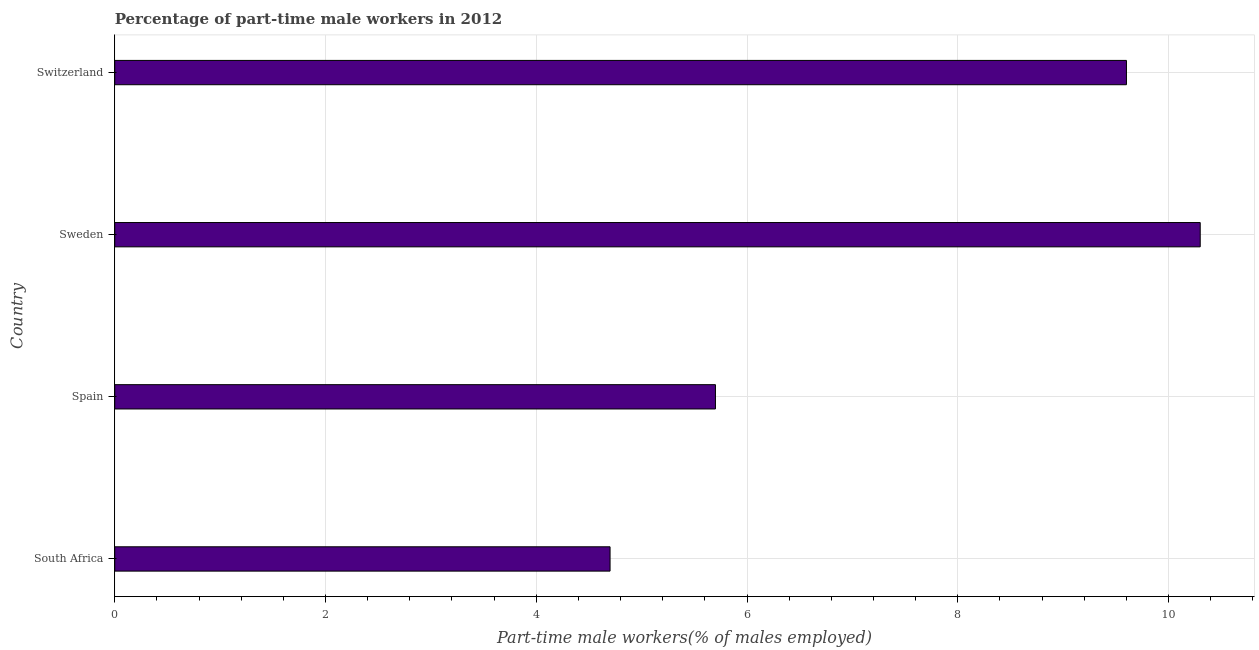Does the graph contain any zero values?
Give a very brief answer. No. What is the title of the graph?
Give a very brief answer. Percentage of part-time male workers in 2012. What is the label or title of the X-axis?
Offer a very short reply. Part-time male workers(% of males employed). What is the label or title of the Y-axis?
Your answer should be compact. Country. What is the percentage of part-time male workers in Sweden?
Give a very brief answer. 10.3. Across all countries, what is the maximum percentage of part-time male workers?
Offer a terse response. 10.3. Across all countries, what is the minimum percentage of part-time male workers?
Make the answer very short. 4.7. In which country was the percentage of part-time male workers maximum?
Your answer should be very brief. Sweden. In which country was the percentage of part-time male workers minimum?
Make the answer very short. South Africa. What is the sum of the percentage of part-time male workers?
Provide a succinct answer. 30.3. What is the average percentage of part-time male workers per country?
Give a very brief answer. 7.58. What is the median percentage of part-time male workers?
Provide a succinct answer. 7.65. What is the ratio of the percentage of part-time male workers in Spain to that in Switzerland?
Your response must be concise. 0.59. Is the percentage of part-time male workers in Spain less than that in Sweden?
Provide a succinct answer. Yes. Is the difference between the percentage of part-time male workers in South Africa and Spain greater than the difference between any two countries?
Offer a terse response. No. In how many countries, is the percentage of part-time male workers greater than the average percentage of part-time male workers taken over all countries?
Keep it short and to the point. 2. How many countries are there in the graph?
Ensure brevity in your answer.  4. What is the Part-time male workers(% of males employed) in South Africa?
Your response must be concise. 4.7. What is the Part-time male workers(% of males employed) in Spain?
Offer a very short reply. 5.7. What is the Part-time male workers(% of males employed) in Sweden?
Your answer should be compact. 10.3. What is the Part-time male workers(% of males employed) in Switzerland?
Give a very brief answer. 9.6. What is the difference between the Part-time male workers(% of males employed) in South Africa and Switzerland?
Provide a succinct answer. -4.9. What is the difference between the Part-time male workers(% of males employed) in Spain and Switzerland?
Your answer should be compact. -3.9. What is the difference between the Part-time male workers(% of males employed) in Sweden and Switzerland?
Offer a terse response. 0.7. What is the ratio of the Part-time male workers(% of males employed) in South Africa to that in Spain?
Offer a terse response. 0.82. What is the ratio of the Part-time male workers(% of males employed) in South Africa to that in Sweden?
Your answer should be very brief. 0.46. What is the ratio of the Part-time male workers(% of males employed) in South Africa to that in Switzerland?
Make the answer very short. 0.49. What is the ratio of the Part-time male workers(% of males employed) in Spain to that in Sweden?
Your answer should be very brief. 0.55. What is the ratio of the Part-time male workers(% of males employed) in Spain to that in Switzerland?
Your response must be concise. 0.59. What is the ratio of the Part-time male workers(% of males employed) in Sweden to that in Switzerland?
Offer a very short reply. 1.07. 